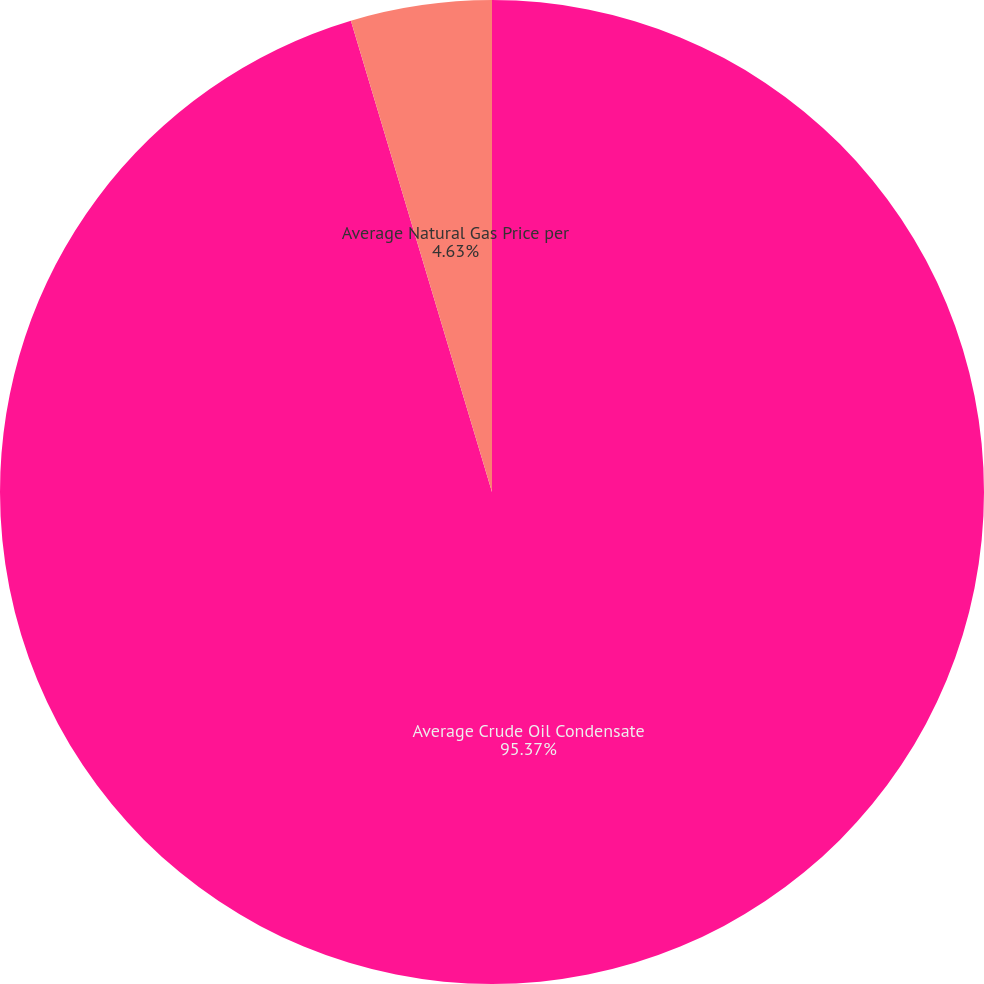Convert chart. <chart><loc_0><loc_0><loc_500><loc_500><pie_chart><fcel>Average Crude Oil Condensate<fcel>Average Natural Gas Price per<nl><fcel>95.37%<fcel>4.63%<nl></chart> 